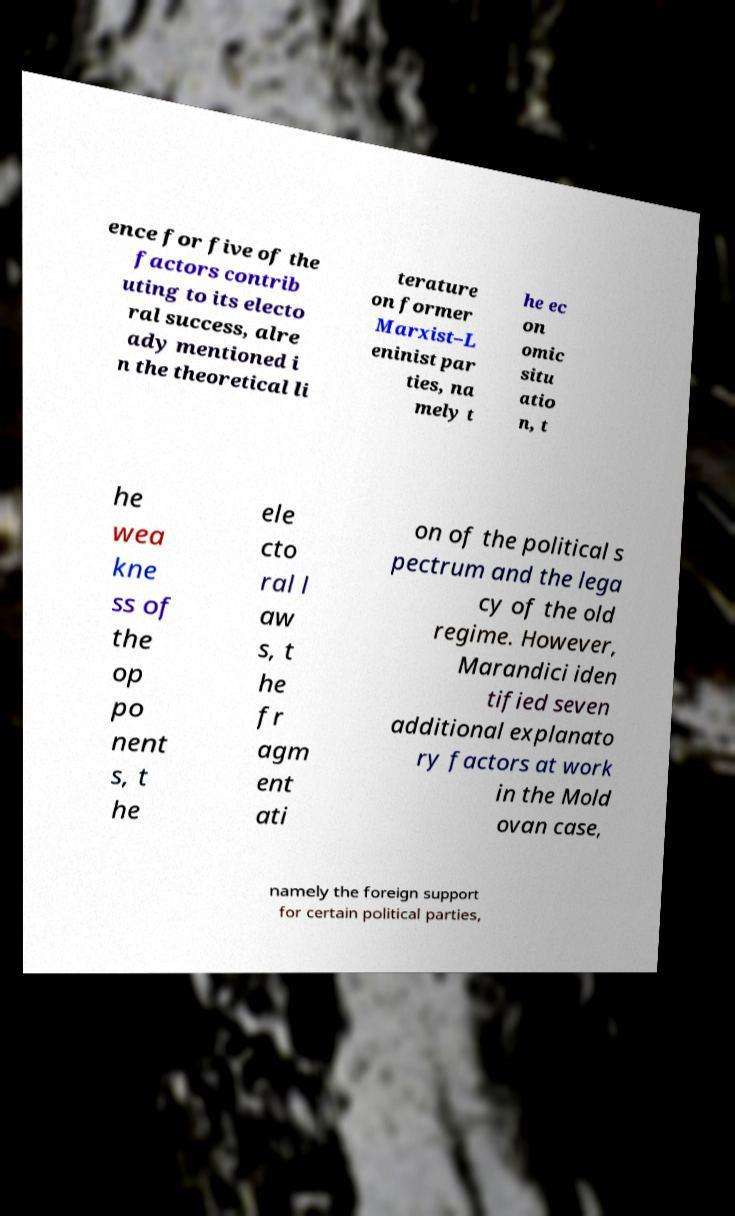Please read and relay the text visible in this image. What does it say? ence for five of the factors contrib uting to its electo ral success, alre ady mentioned i n the theoretical li terature on former Marxist–L eninist par ties, na mely t he ec on omic situ atio n, t he wea kne ss of the op po nent s, t he ele cto ral l aw s, t he fr agm ent ati on of the political s pectrum and the lega cy of the old regime. However, Marandici iden tified seven additional explanato ry factors at work in the Mold ovan case, namely the foreign support for certain political parties, 